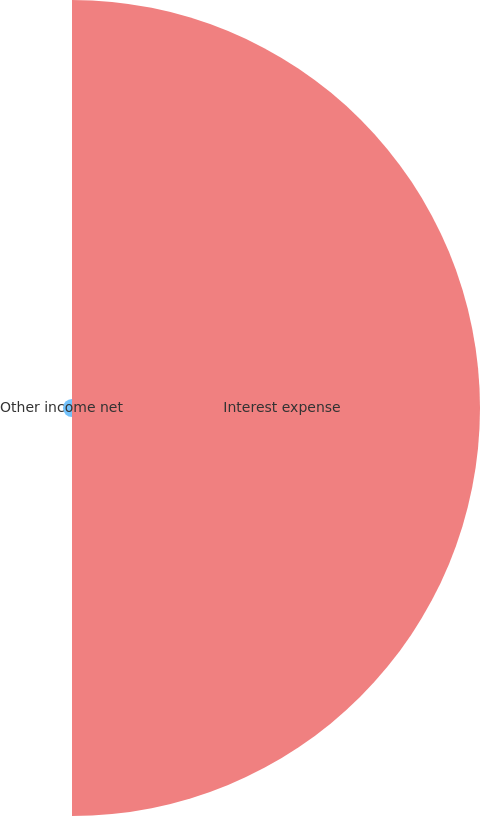<chart> <loc_0><loc_0><loc_500><loc_500><pie_chart><fcel>Interest expense<fcel>Other income net<nl><fcel>97.83%<fcel>2.17%<nl></chart> 